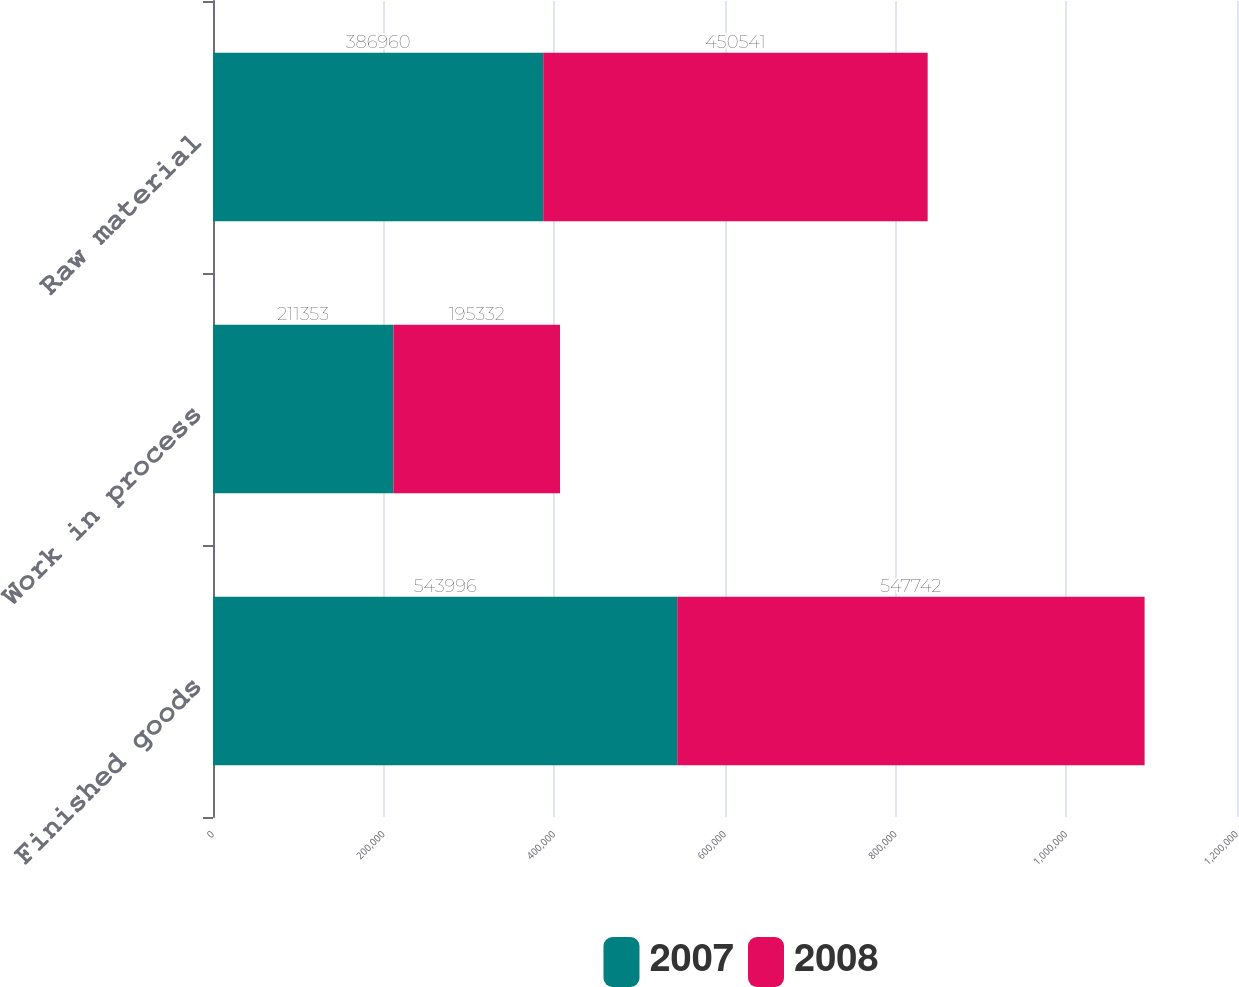Convert chart. <chart><loc_0><loc_0><loc_500><loc_500><stacked_bar_chart><ecel><fcel>Finished goods<fcel>Work in process<fcel>Raw material<nl><fcel>2007<fcel>543996<fcel>211353<fcel>386960<nl><fcel>2008<fcel>547742<fcel>195332<fcel>450541<nl></chart> 